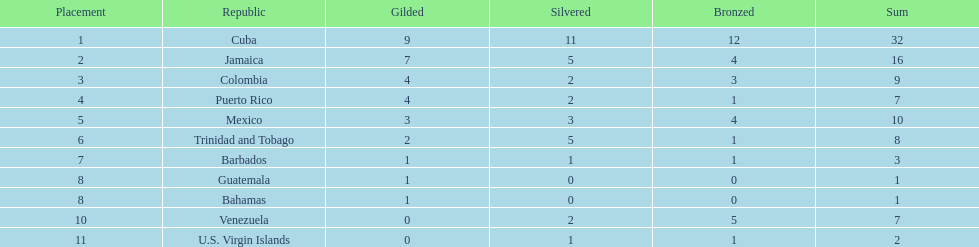Which country was awarded more than 5 silver medals? Cuba. 